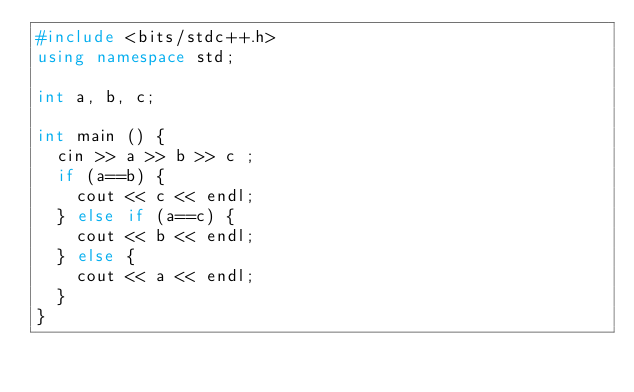<code> <loc_0><loc_0><loc_500><loc_500><_C++_>#include <bits/stdc++.h>
using namespace std;

int a, b, c;

int main () {
	cin >> a >> b >> c ;
	if (a==b) {
		cout << c << endl;
	} else if (a==c) {
		cout << b << endl;
	} else {
		cout << a << endl;
	}
}</code> 